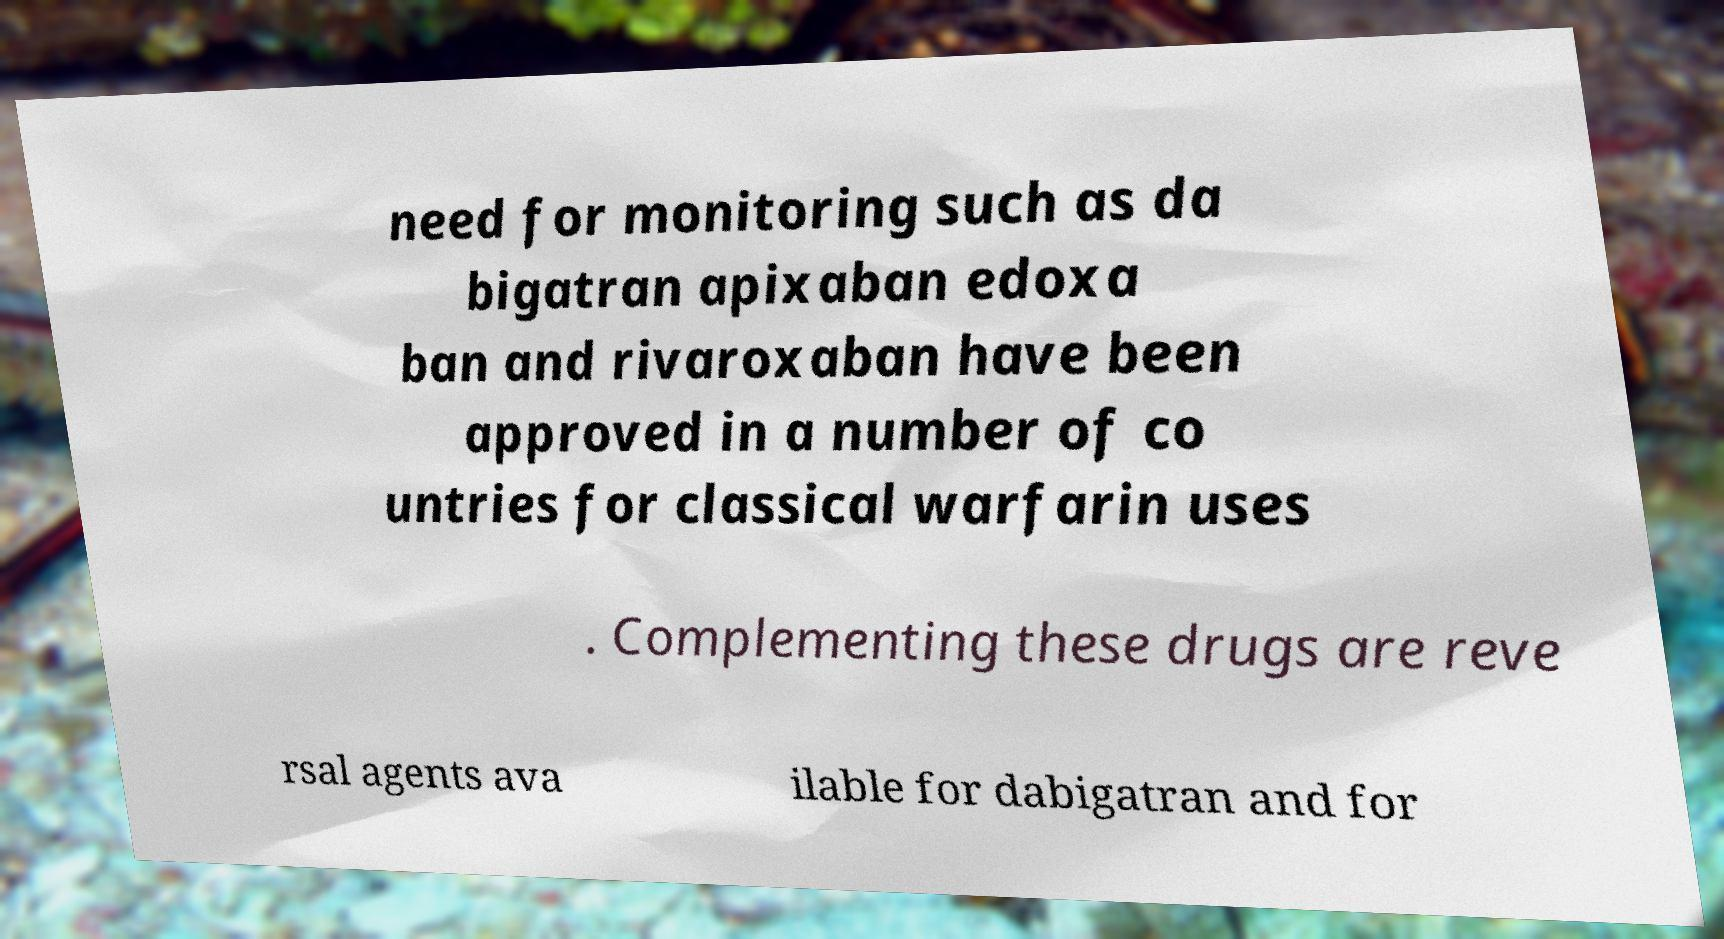What messages or text are displayed in this image? I need them in a readable, typed format. need for monitoring such as da bigatran apixaban edoxa ban and rivaroxaban have been approved in a number of co untries for classical warfarin uses . Complementing these drugs are reve rsal agents ava ilable for dabigatran and for 